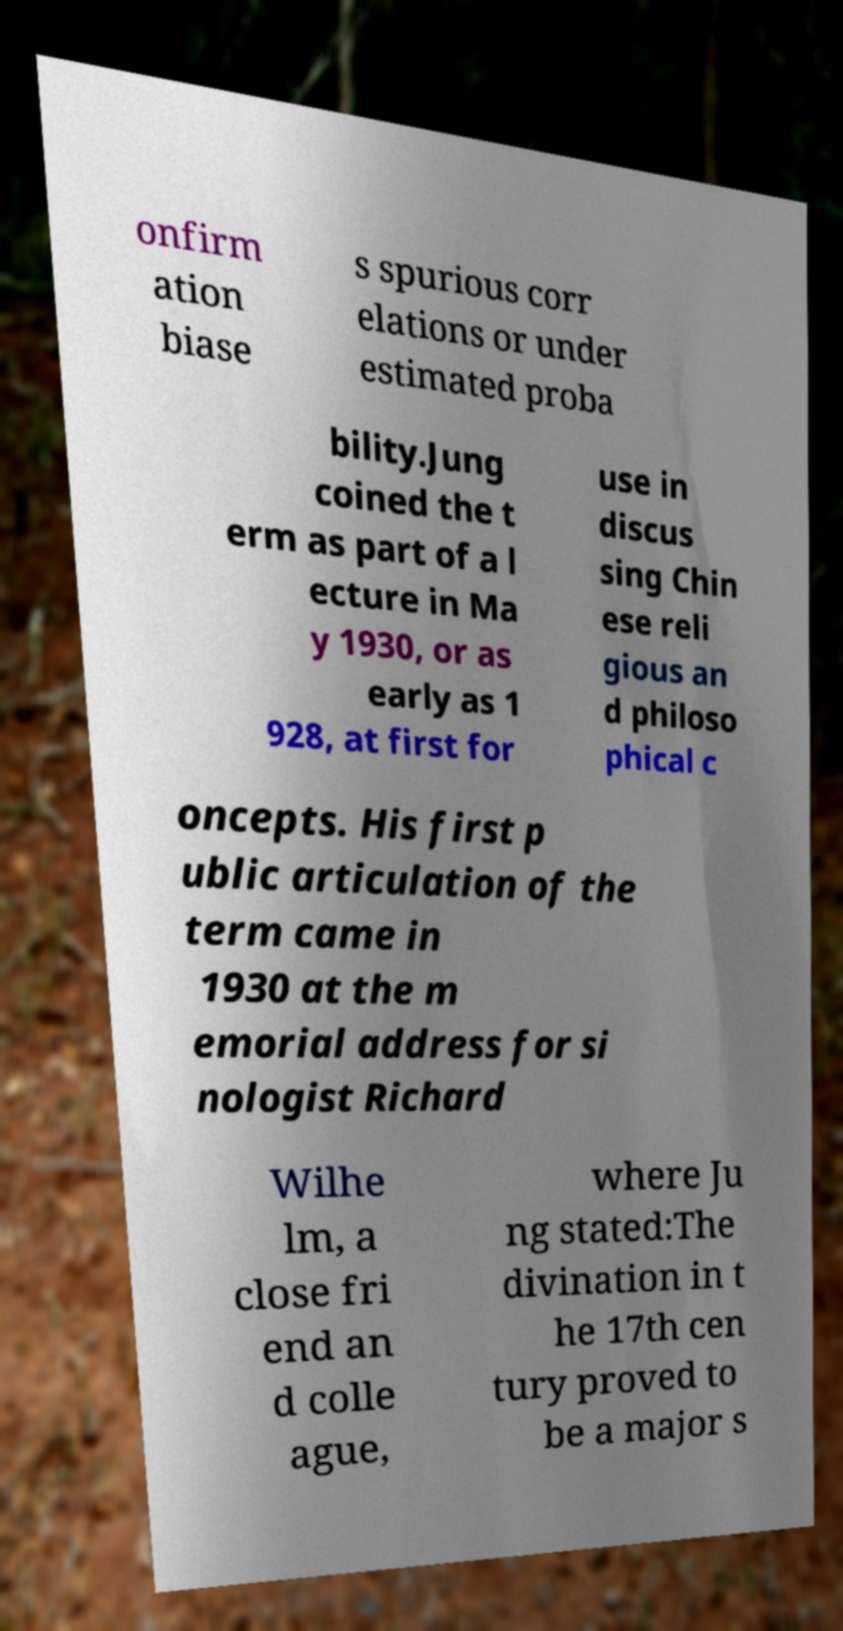There's text embedded in this image that I need extracted. Can you transcribe it verbatim? onfirm ation biase s spurious corr elations or under estimated proba bility.Jung coined the t erm as part of a l ecture in Ma y 1930, or as early as 1 928, at first for use in discus sing Chin ese reli gious an d philoso phical c oncepts. His first p ublic articulation of the term came in 1930 at the m emorial address for si nologist Richard Wilhe lm, a close fri end an d colle ague, where Ju ng stated:The divination in t he 17th cen tury proved to be a major s 